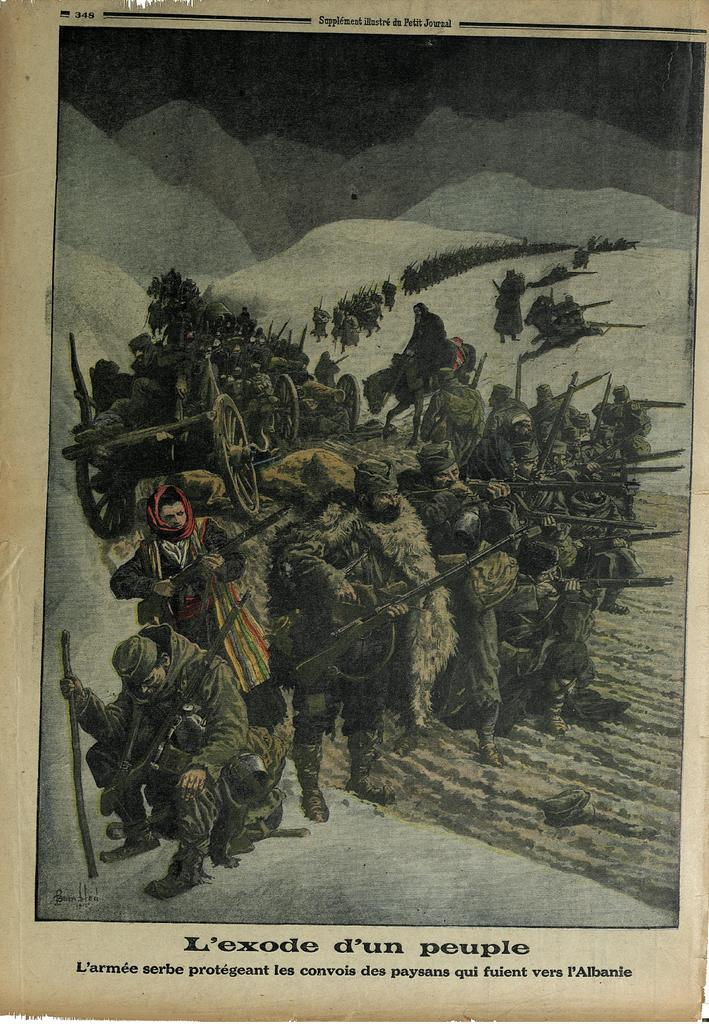What is present in the image that contains visual information? There is a poster in the image. What types of content can be found on the poster? The poster contains images and text. How many cacti are depicted on the poster? There is no mention of cacti in the image or the provided facts, so it cannot be determined if any are present on the poster. 